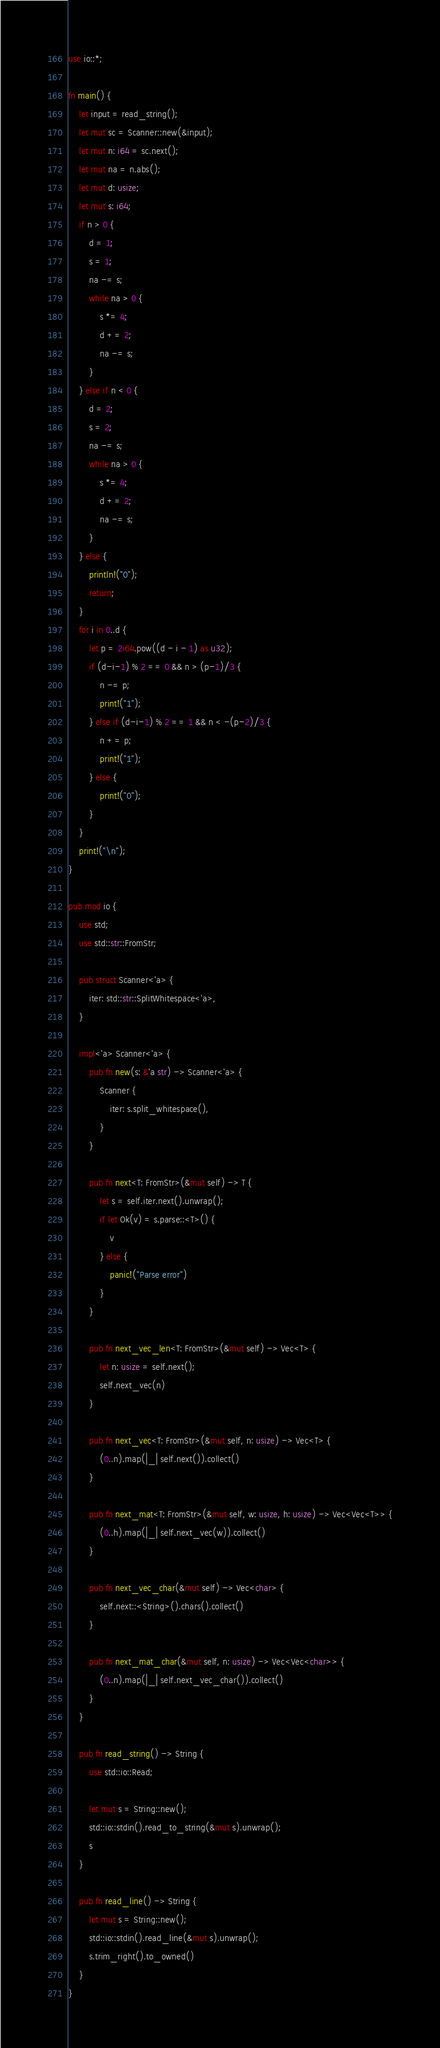Convert code to text. <code><loc_0><loc_0><loc_500><loc_500><_Rust_>use io::*;

fn main() {
    let input = read_string();
    let mut sc = Scanner::new(&input);
    let mut n: i64 = sc.next();
    let mut na = n.abs();
    let mut d: usize;
    let mut s: i64;
    if n > 0 {
        d = 1;
        s = 1;
        na -= s;
        while na > 0 {
            s *= 4;
            d += 2;
            na -= s;
        }
    } else if n < 0 {
        d = 2;
        s = 2;
        na -= s;
        while na > 0 {
            s *= 4;
            d += 2;
            na -= s;
        }
    } else {
        println!("0");
        return;
    }
    for i in 0..d {
        let p = 2i64.pow((d - i - 1) as u32);
        if (d-i-1) % 2 == 0 && n > (p-1)/3 {
            n -= p;
            print!("1");
        } else if (d-i-1) % 2 == 1 && n < -(p-2)/3 {
            n += p;
            print!("1");
        } else {
            print!("0");
        }
    }
    print!("\n");
}

pub mod io {
    use std;
    use std::str::FromStr;

    pub struct Scanner<'a> {
        iter: std::str::SplitWhitespace<'a>,
    }

    impl<'a> Scanner<'a> {
        pub fn new(s: &'a str) -> Scanner<'a> {
            Scanner {
                iter: s.split_whitespace(),
            }
        }

        pub fn next<T: FromStr>(&mut self) -> T {
            let s = self.iter.next().unwrap();
            if let Ok(v) = s.parse::<T>() {
                v
            } else {
                panic!("Parse error")
            }
        }

        pub fn next_vec_len<T: FromStr>(&mut self) -> Vec<T> {
            let n: usize = self.next();
            self.next_vec(n)
        }

        pub fn next_vec<T: FromStr>(&mut self, n: usize) -> Vec<T> {
            (0..n).map(|_| self.next()).collect()
        }

        pub fn next_mat<T: FromStr>(&mut self, w: usize, h: usize) -> Vec<Vec<T>> {
            (0..h).map(|_| self.next_vec(w)).collect()
        }

        pub fn next_vec_char(&mut self) -> Vec<char> {
            self.next::<String>().chars().collect()
        }

        pub fn next_mat_char(&mut self, n: usize) -> Vec<Vec<char>> {
            (0..n).map(|_| self.next_vec_char()).collect()
        }
    }

    pub fn read_string() -> String {
        use std::io::Read;

        let mut s = String::new();
        std::io::stdin().read_to_string(&mut s).unwrap();
        s
    }

    pub fn read_line() -> String {
        let mut s = String::new();
        std::io::stdin().read_line(&mut s).unwrap();
        s.trim_right().to_owned()
    }
}
</code> 